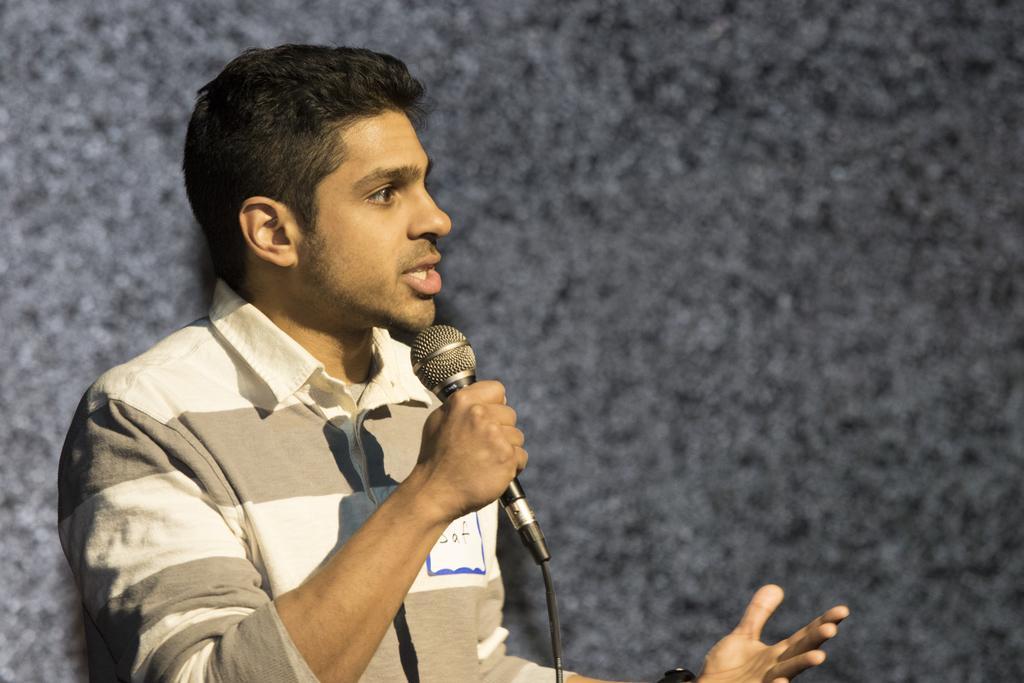Could you give a brief overview of what you see in this image? In the image we can see a man standing on the left side of the image. The man is wearing clothes and holding a microphone in hand, and the man is talking. Here we can see cable wire and the background is slightly blurred. 